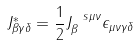<formula> <loc_0><loc_0><loc_500><loc_500>J ^ { * } _ { \beta \gamma \delta } = \frac { 1 } { 2 } J _ { \beta } ^ { \ s \mu \nu } \epsilon _ { \mu \nu \gamma \delta }</formula> 